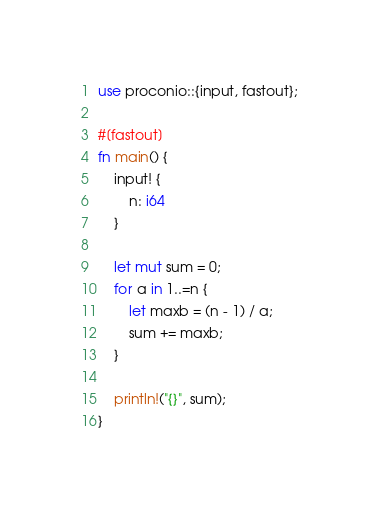<code> <loc_0><loc_0><loc_500><loc_500><_Rust_>use proconio::{input, fastout};

#[fastout]
fn main() {
    input! {
        n: i64
    }

    let mut sum = 0;
    for a in 1..=n {
        let maxb = (n - 1) / a;
        sum += maxb;
    }

    println!("{}", sum);
}
</code> 